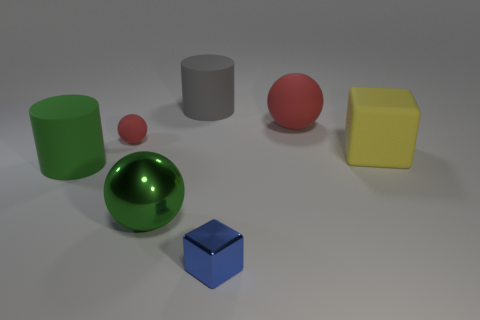There is a rubber object that is in front of the big yellow cube; what size is it?
Give a very brief answer. Large. Is the size of the green sphere the same as the gray matte cylinder?
Provide a short and direct response. Yes. What number of cylinders are in front of the yellow object and behind the yellow matte thing?
Give a very brief answer. 0. What number of yellow things are shiny objects or big blocks?
Offer a very short reply. 1. What number of metal things are either large yellow cubes or blue balls?
Provide a succinct answer. 0. Is there a big purple object?
Your answer should be very brief. No. Does the tiny red matte object have the same shape as the large yellow object?
Give a very brief answer. No. There is a ball that is in front of the block behind the green metal object; what number of rubber balls are to the left of it?
Ensure brevity in your answer.  1. What is the ball that is both to the left of the small blue metal cube and behind the large yellow cube made of?
Make the answer very short. Rubber. There is a thing that is both in front of the small red object and on the left side of the green sphere; what color is it?
Your response must be concise. Green. 